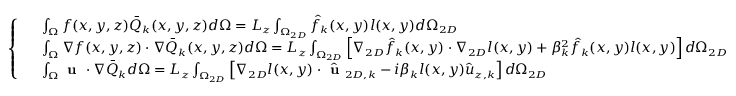<formula> <loc_0><loc_0><loc_500><loc_500>\left \{ \begin{array} { r l } & { \int _ { \Omega } f ( x , y , z ) \bar { Q } _ { k } ( x , y , z ) d \Omega = L _ { z } \int _ { \Omega _ { 2 D } } \hat { f } _ { k } ( x , y ) l ( x , y ) d \Omega _ { 2 D } } \\ & { \int _ { \Omega } \nabla f ( x , y , z ) \cdot \nabla \bar { Q } _ { k } ( x , y , z ) d \Omega = L _ { z } \int _ { \Omega _ { 2 D } } \left [ \nabla _ { 2 D } \hat { f } _ { k } ( x , y ) \cdot \nabla _ { 2 D } l ( x , y ) + \beta _ { k } ^ { 2 } \hat { f } _ { k } ( x , y ) l ( x , y ) \right ] d \Omega _ { 2 D } } \\ & { \int _ { \Omega } u \cdot \nabla \bar { Q } _ { k } d \Omega = L _ { z } \int _ { \Omega _ { 2 D } } \left [ \nabla _ { 2 D } l ( x , y ) \cdot \hat { u } _ { 2 D , k } - i \beta _ { k } l ( x , y ) \hat { u } _ { z , k } \right ] d \Omega _ { 2 D } } \end{array}</formula> 